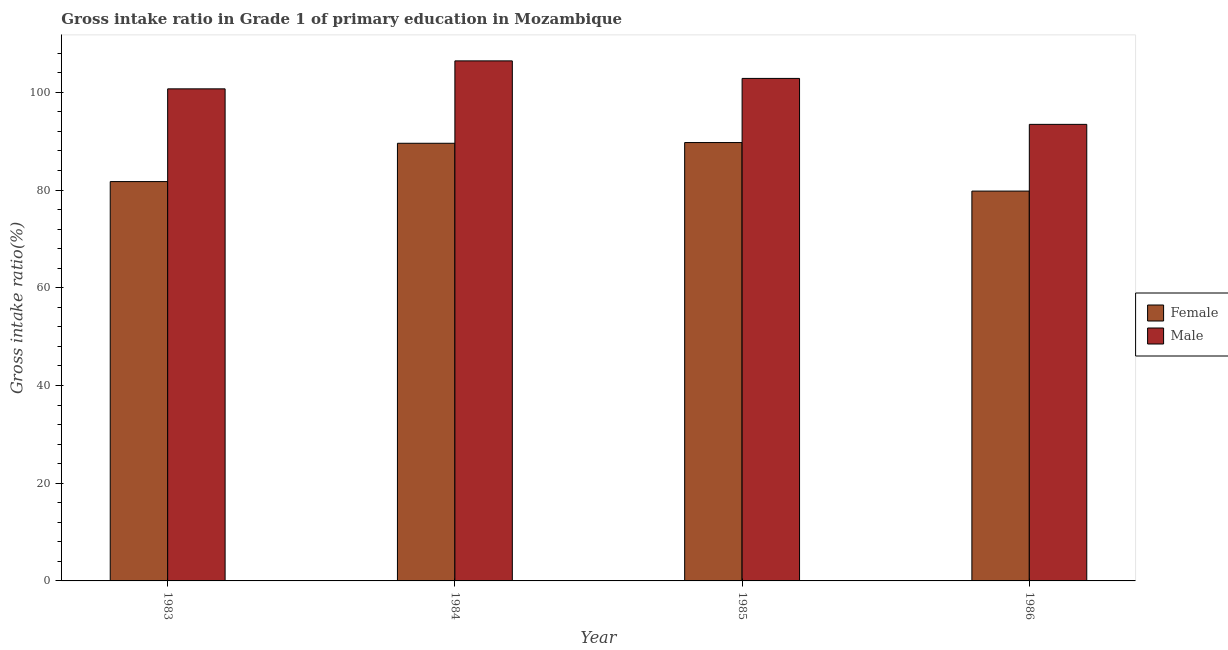How many different coloured bars are there?
Make the answer very short. 2. How many groups of bars are there?
Offer a very short reply. 4. How many bars are there on the 2nd tick from the right?
Your response must be concise. 2. What is the label of the 1st group of bars from the left?
Provide a short and direct response. 1983. In how many cases, is the number of bars for a given year not equal to the number of legend labels?
Offer a terse response. 0. What is the gross intake ratio(female) in 1984?
Make the answer very short. 89.57. Across all years, what is the maximum gross intake ratio(male)?
Offer a very short reply. 106.44. Across all years, what is the minimum gross intake ratio(male)?
Ensure brevity in your answer.  93.44. In which year was the gross intake ratio(male) minimum?
Offer a very short reply. 1986. What is the total gross intake ratio(male) in the graph?
Keep it short and to the point. 403.44. What is the difference between the gross intake ratio(female) in 1983 and that in 1984?
Make the answer very short. -7.84. What is the difference between the gross intake ratio(female) in 1986 and the gross intake ratio(male) in 1983?
Provide a short and direct response. -1.95. What is the average gross intake ratio(female) per year?
Your answer should be compact. 85.2. In the year 1986, what is the difference between the gross intake ratio(male) and gross intake ratio(female)?
Offer a terse response. 0. In how many years, is the gross intake ratio(male) greater than 52 %?
Offer a terse response. 4. What is the ratio of the gross intake ratio(female) in 1985 to that in 1986?
Your answer should be very brief. 1.12. Is the gross intake ratio(female) in 1984 less than that in 1986?
Provide a short and direct response. No. Is the difference between the gross intake ratio(male) in 1983 and 1986 greater than the difference between the gross intake ratio(female) in 1983 and 1986?
Keep it short and to the point. No. What is the difference between the highest and the second highest gross intake ratio(male)?
Offer a very short reply. 3.59. What is the difference between the highest and the lowest gross intake ratio(male)?
Your response must be concise. 13. Is the sum of the gross intake ratio(female) in 1983 and 1985 greater than the maximum gross intake ratio(male) across all years?
Your answer should be compact. Yes. What does the 2nd bar from the right in 1986 represents?
Provide a short and direct response. Female. Are all the bars in the graph horizontal?
Keep it short and to the point. No. How many years are there in the graph?
Your response must be concise. 4. What is the difference between two consecutive major ticks on the Y-axis?
Keep it short and to the point. 20. Are the values on the major ticks of Y-axis written in scientific E-notation?
Your answer should be compact. No. What is the title of the graph?
Ensure brevity in your answer.  Gross intake ratio in Grade 1 of primary education in Mozambique. Does "Health Care" appear as one of the legend labels in the graph?
Provide a succinct answer. No. What is the label or title of the X-axis?
Ensure brevity in your answer.  Year. What is the label or title of the Y-axis?
Provide a short and direct response. Gross intake ratio(%). What is the Gross intake ratio(%) in Female in 1983?
Your answer should be very brief. 81.73. What is the Gross intake ratio(%) in Male in 1983?
Offer a terse response. 100.71. What is the Gross intake ratio(%) in Female in 1984?
Ensure brevity in your answer.  89.57. What is the Gross intake ratio(%) in Male in 1984?
Your answer should be very brief. 106.44. What is the Gross intake ratio(%) of Female in 1985?
Offer a terse response. 89.72. What is the Gross intake ratio(%) of Male in 1985?
Ensure brevity in your answer.  102.85. What is the Gross intake ratio(%) of Female in 1986?
Ensure brevity in your answer.  79.79. What is the Gross intake ratio(%) of Male in 1986?
Keep it short and to the point. 93.44. Across all years, what is the maximum Gross intake ratio(%) in Female?
Your answer should be compact. 89.72. Across all years, what is the maximum Gross intake ratio(%) in Male?
Provide a succinct answer. 106.44. Across all years, what is the minimum Gross intake ratio(%) of Female?
Your answer should be compact. 79.79. Across all years, what is the minimum Gross intake ratio(%) in Male?
Keep it short and to the point. 93.44. What is the total Gross intake ratio(%) in Female in the graph?
Give a very brief answer. 340.81. What is the total Gross intake ratio(%) of Male in the graph?
Offer a terse response. 403.44. What is the difference between the Gross intake ratio(%) of Female in 1983 and that in 1984?
Provide a succinct answer. -7.84. What is the difference between the Gross intake ratio(%) of Male in 1983 and that in 1984?
Your answer should be compact. -5.73. What is the difference between the Gross intake ratio(%) of Female in 1983 and that in 1985?
Offer a terse response. -7.99. What is the difference between the Gross intake ratio(%) in Male in 1983 and that in 1985?
Your answer should be compact. -2.14. What is the difference between the Gross intake ratio(%) in Female in 1983 and that in 1986?
Offer a very short reply. 1.95. What is the difference between the Gross intake ratio(%) of Male in 1983 and that in 1986?
Provide a succinct answer. 7.27. What is the difference between the Gross intake ratio(%) of Female in 1984 and that in 1985?
Offer a very short reply. -0.15. What is the difference between the Gross intake ratio(%) of Male in 1984 and that in 1985?
Your answer should be compact. 3.59. What is the difference between the Gross intake ratio(%) of Female in 1984 and that in 1986?
Your answer should be very brief. 9.79. What is the difference between the Gross intake ratio(%) of Male in 1984 and that in 1986?
Make the answer very short. 13. What is the difference between the Gross intake ratio(%) of Female in 1985 and that in 1986?
Your answer should be very brief. 9.93. What is the difference between the Gross intake ratio(%) of Male in 1985 and that in 1986?
Provide a succinct answer. 9.41. What is the difference between the Gross intake ratio(%) of Female in 1983 and the Gross intake ratio(%) of Male in 1984?
Offer a very short reply. -24.71. What is the difference between the Gross intake ratio(%) in Female in 1983 and the Gross intake ratio(%) in Male in 1985?
Your response must be concise. -21.12. What is the difference between the Gross intake ratio(%) of Female in 1983 and the Gross intake ratio(%) of Male in 1986?
Provide a succinct answer. -11.71. What is the difference between the Gross intake ratio(%) in Female in 1984 and the Gross intake ratio(%) in Male in 1985?
Provide a succinct answer. -13.28. What is the difference between the Gross intake ratio(%) in Female in 1984 and the Gross intake ratio(%) in Male in 1986?
Offer a very short reply. -3.87. What is the difference between the Gross intake ratio(%) of Female in 1985 and the Gross intake ratio(%) of Male in 1986?
Your response must be concise. -3.72. What is the average Gross intake ratio(%) of Female per year?
Keep it short and to the point. 85.2. What is the average Gross intake ratio(%) in Male per year?
Your answer should be very brief. 100.86. In the year 1983, what is the difference between the Gross intake ratio(%) of Female and Gross intake ratio(%) of Male?
Your answer should be very brief. -18.98. In the year 1984, what is the difference between the Gross intake ratio(%) in Female and Gross intake ratio(%) in Male?
Your answer should be compact. -16.87. In the year 1985, what is the difference between the Gross intake ratio(%) of Female and Gross intake ratio(%) of Male?
Your answer should be compact. -13.13. In the year 1986, what is the difference between the Gross intake ratio(%) of Female and Gross intake ratio(%) of Male?
Your answer should be compact. -13.66. What is the ratio of the Gross intake ratio(%) of Female in 1983 to that in 1984?
Provide a short and direct response. 0.91. What is the ratio of the Gross intake ratio(%) in Male in 1983 to that in 1984?
Your response must be concise. 0.95. What is the ratio of the Gross intake ratio(%) of Female in 1983 to that in 1985?
Provide a short and direct response. 0.91. What is the ratio of the Gross intake ratio(%) of Male in 1983 to that in 1985?
Make the answer very short. 0.98. What is the ratio of the Gross intake ratio(%) in Female in 1983 to that in 1986?
Your response must be concise. 1.02. What is the ratio of the Gross intake ratio(%) of Male in 1983 to that in 1986?
Ensure brevity in your answer.  1.08. What is the ratio of the Gross intake ratio(%) in Female in 1984 to that in 1985?
Offer a very short reply. 1. What is the ratio of the Gross intake ratio(%) of Male in 1984 to that in 1985?
Make the answer very short. 1.03. What is the ratio of the Gross intake ratio(%) in Female in 1984 to that in 1986?
Give a very brief answer. 1.12. What is the ratio of the Gross intake ratio(%) of Male in 1984 to that in 1986?
Give a very brief answer. 1.14. What is the ratio of the Gross intake ratio(%) in Female in 1985 to that in 1986?
Offer a terse response. 1.12. What is the ratio of the Gross intake ratio(%) in Male in 1985 to that in 1986?
Offer a very short reply. 1.1. What is the difference between the highest and the second highest Gross intake ratio(%) in Female?
Offer a terse response. 0.15. What is the difference between the highest and the second highest Gross intake ratio(%) in Male?
Give a very brief answer. 3.59. What is the difference between the highest and the lowest Gross intake ratio(%) in Female?
Your answer should be very brief. 9.93. What is the difference between the highest and the lowest Gross intake ratio(%) of Male?
Ensure brevity in your answer.  13. 